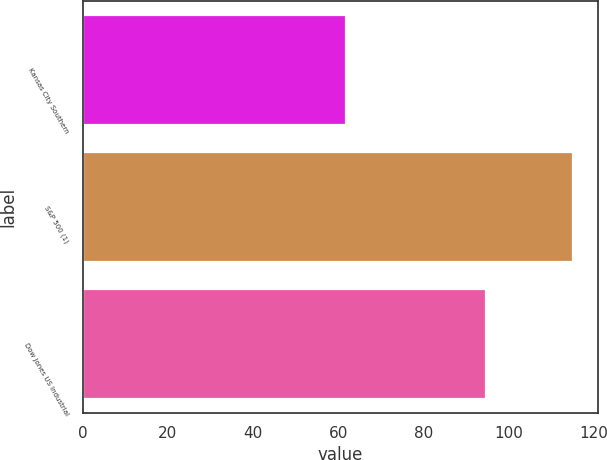<chart> <loc_0><loc_0><loc_500><loc_500><bar_chart><fcel>Kansas City Southern<fcel>S&P 500 (1)<fcel>Dow Jones US Industrial<nl><fcel>61.8<fcel>115.26<fcel>94.72<nl></chart> 